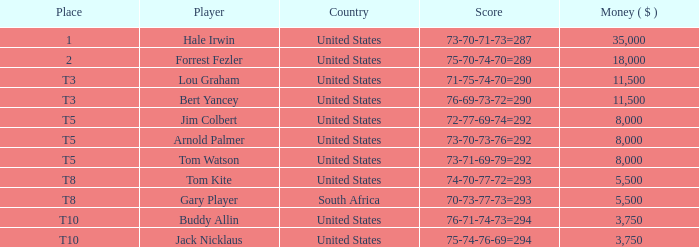Which country's score of 72-77-69-74=292 resulted in a reward of over $5,500? United States. 